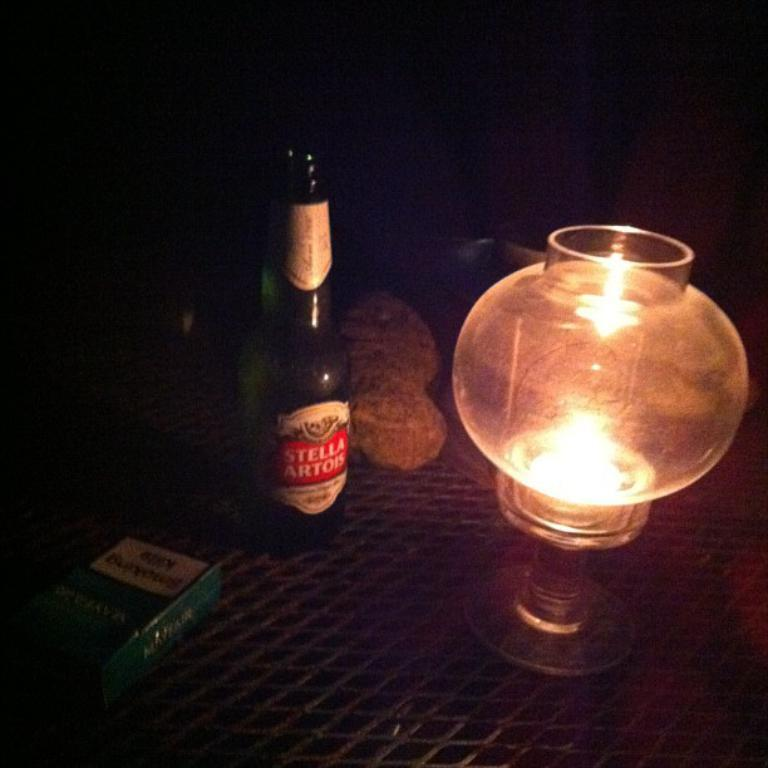Provide a one-sentence caption for the provided image. A bottle of Stella Artois beer is next to a candle and a pack of cigarettes. 